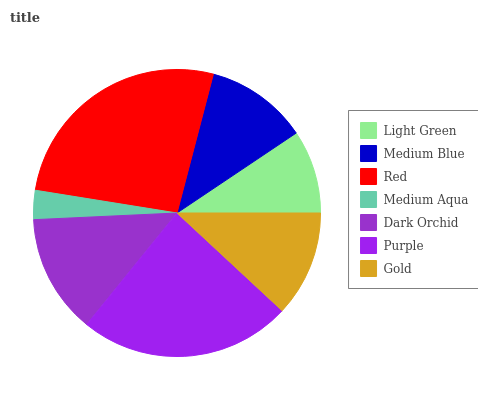Is Medium Aqua the minimum?
Answer yes or no. Yes. Is Red the maximum?
Answer yes or no. Yes. Is Medium Blue the minimum?
Answer yes or no. No. Is Medium Blue the maximum?
Answer yes or no. No. Is Medium Blue greater than Light Green?
Answer yes or no. Yes. Is Light Green less than Medium Blue?
Answer yes or no. Yes. Is Light Green greater than Medium Blue?
Answer yes or no. No. Is Medium Blue less than Light Green?
Answer yes or no. No. Is Gold the high median?
Answer yes or no. Yes. Is Gold the low median?
Answer yes or no. Yes. Is Medium Blue the high median?
Answer yes or no. No. Is Dark Orchid the low median?
Answer yes or no. No. 